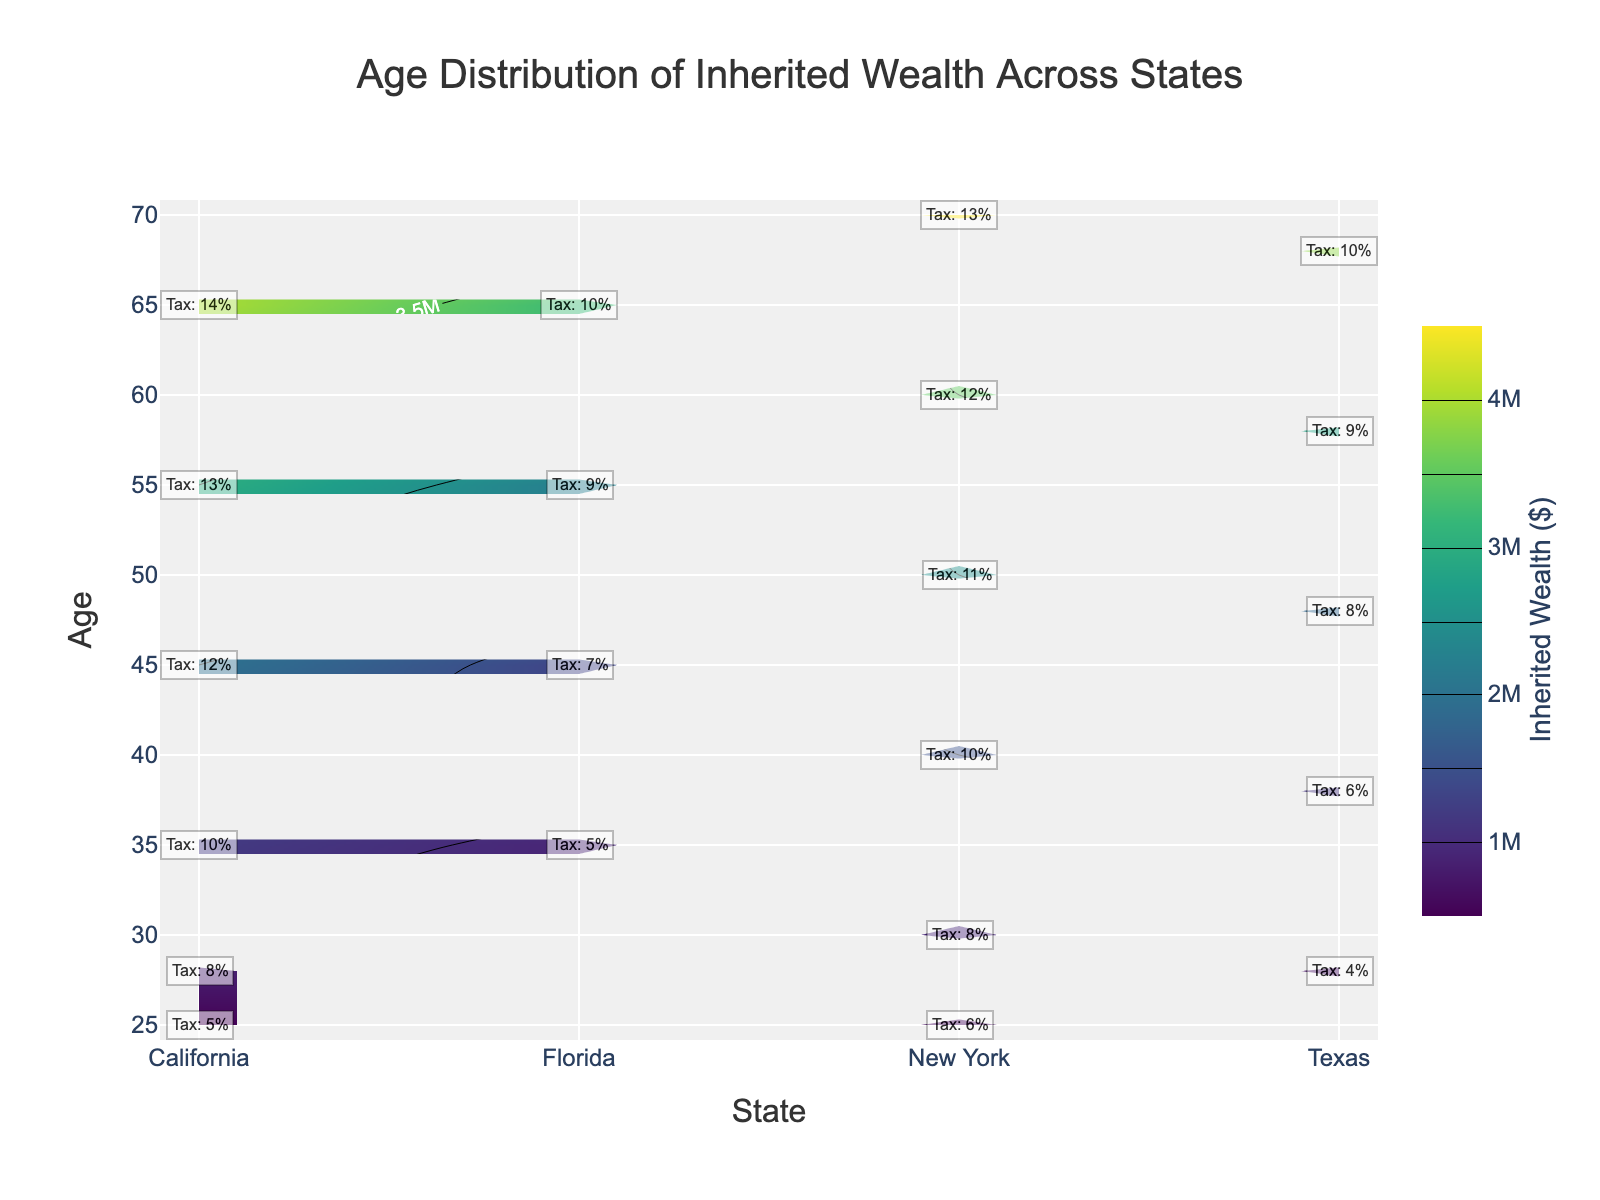What is the title of the figure? The title is usually found at the top of the figure and is mentioned explicitly for reference.
Answer: Age Distribution of Inherited Wealth Across States What is the color used for the highest inherited wealth on the color scale? The highest values on the color scale are usually marked by the color corresponding to the highest end of the scale in a contour plot.
Answer: A shade of yellow Which state shows the highest amount of inherited wealth for individuals aged 65? Look at the 65-year-old age line on the y-axis and find the state along the x-axis that corresponds to the highest value on this line as indicated by the contour colors and labels.
Answer: California What is the inherited wealth for a 45-year-old in New York? By locating 45 on the y-axis and tracing horizontally to the contour that intersects with New York, we can identify the associated inherited wealth amount.
Answer: $2,000,000 Between ages 35 and 45, which state has the most significant increase in inherited wealth? Calculate the difference between the inherited wealth values at ages 35 and 45 for each state and compare these differences.
Answer: California What is the estate tax bracket for a 50-year-old in New York? Locate the annotation labels corresponding to a 50-year-old along the y-axis for New York and read the stated tax bracket.
Answer: 11% Which state has the lowest inherited wealth for individuals aged 55? Identify the state with the lowest value on the contour plot lines corresponding to the age of 55.
Answer: Florida How does the inherited wealth of a 28-year-old compare across the different states? Identify the values of inherited wealth for 28-year-olds in California, New York, and Texas and compare these values to see which is highest, lowest, or equal.
Answer: New York > Texas > California What is the total tax rate difference between a 30-year-old in New York and a 38-year-old in Texas? Check the tax bracket annotations for a 30-year-old in New York and a 38-year-old in Texas, then subtract the two values.
Answer: 2% How does the distribution of inherited wealth change with age in Florida? Observe the trend of contour lines and their associated values for different ages in Florida to determine how wealth distribution increases or decreases with age.
Answer: Increases with age 